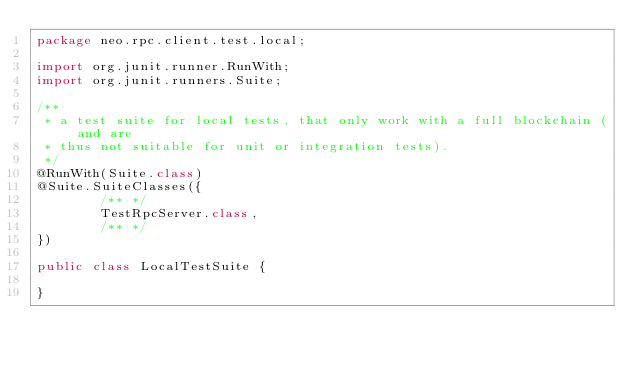<code> <loc_0><loc_0><loc_500><loc_500><_Java_>package neo.rpc.client.test.local;

import org.junit.runner.RunWith;
import org.junit.runners.Suite;

/**
 * a test suite for local tests, that only work with a full blockchain (and are
 * thus not suitable for unit or integration tests).
 */
@RunWith(Suite.class)
@Suite.SuiteClasses({
		/** */
		TestRpcServer.class,
		/** */
})

public class LocalTestSuite {

}
</code> 